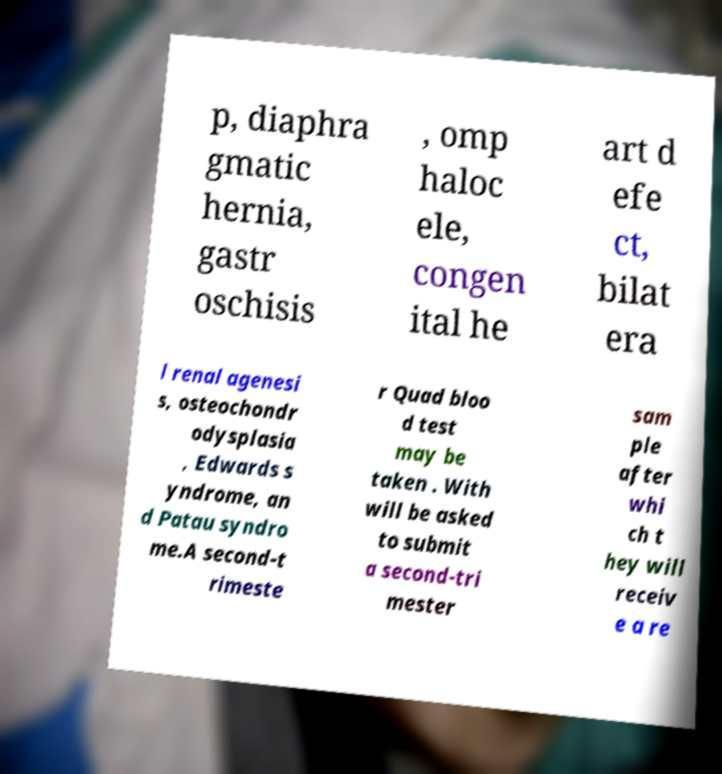Could you assist in decoding the text presented in this image and type it out clearly? p, diaphra gmatic hernia, gastr oschisis , omp haloc ele, congen ital he art d efe ct, bilat era l renal agenesi s, osteochondr odysplasia , Edwards s yndrome, an d Patau syndro me.A second-t rimeste r Quad bloo d test may be taken . With will be asked to submit a second-tri mester sam ple after whi ch t hey will receiv e a re 